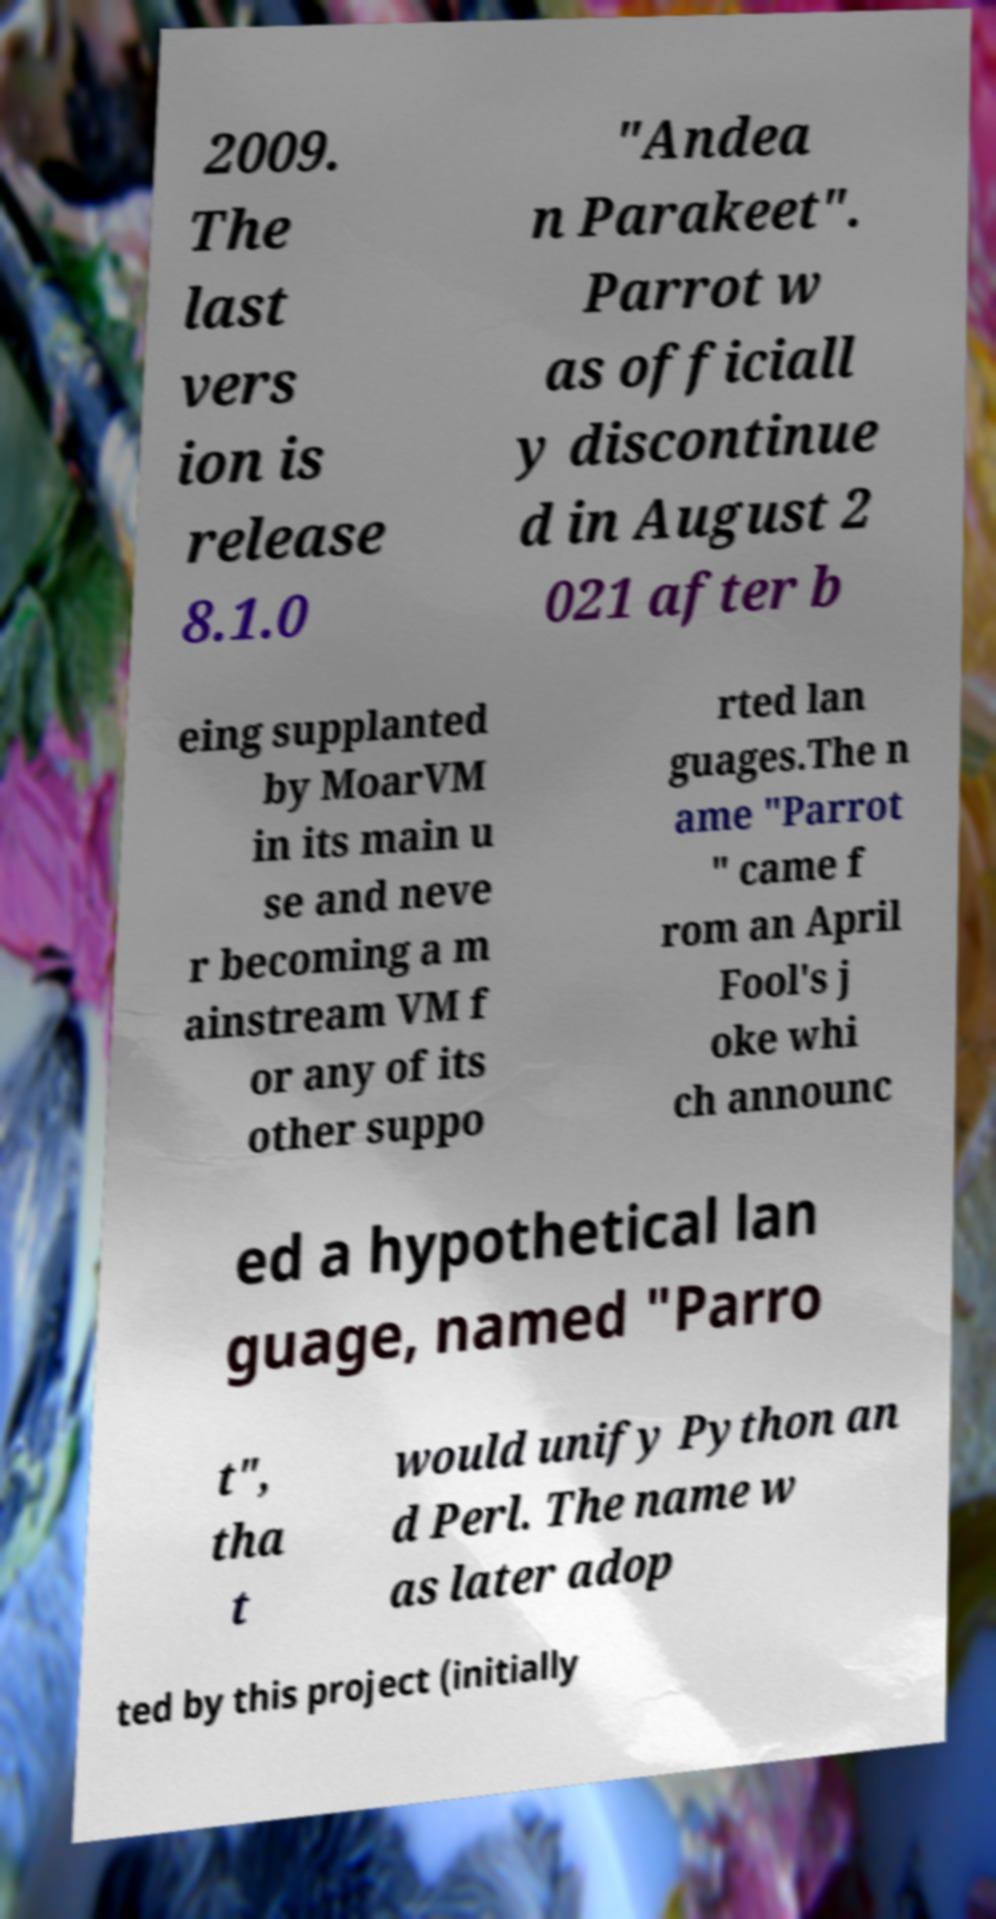There's text embedded in this image that I need extracted. Can you transcribe it verbatim? 2009. The last vers ion is release 8.1.0 "Andea n Parakeet". Parrot w as officiall y discontinue d in August 2 021 after b eing supplanted by MoarVM in its main u se and neve r becoming a m ainstream VM f or any of its other suppo rted lan guages.The n ame "Parrot " came f rom an April Fool's j oke whi ch announc ed a hypothetical lan guage, named "Parro t", tha t would unify Python an d Perl. The name w as later adop ted by this project (initially 